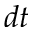Convert formula to latex. <formula><loc_0><loc_0><loc_500><loc_500>d t</formula> 